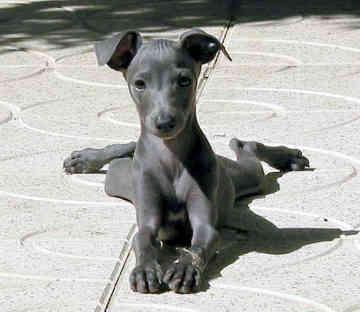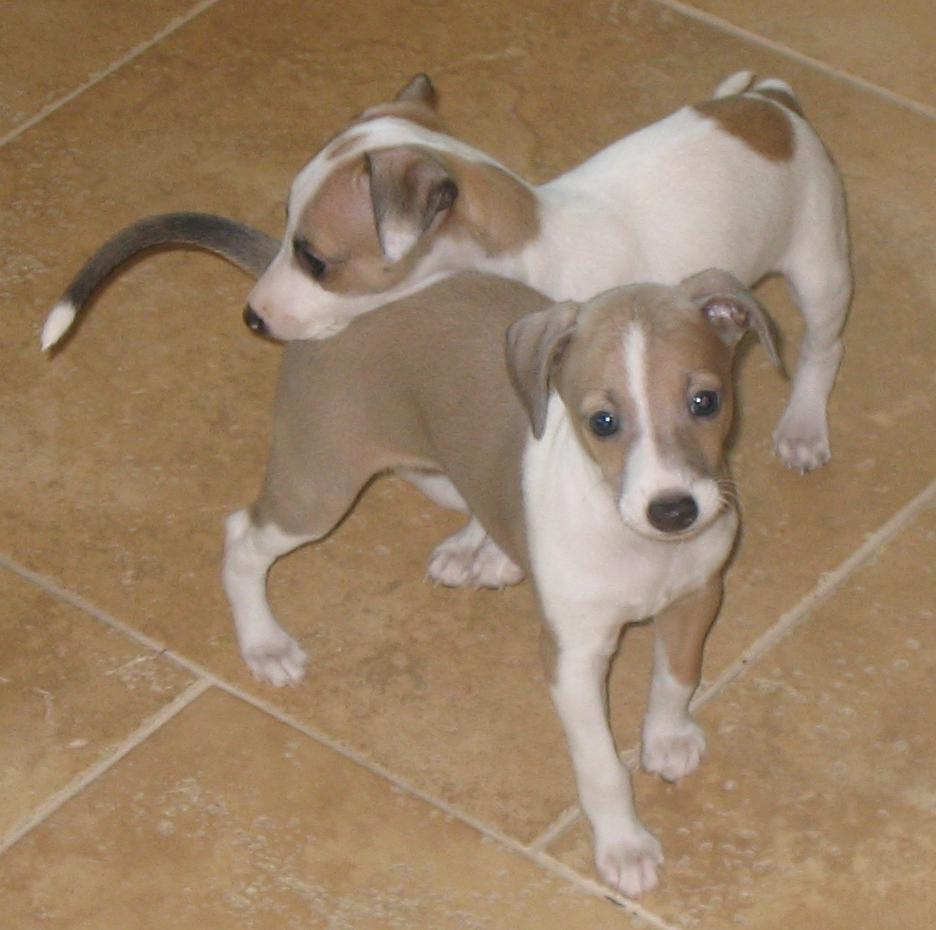The first image is the image on the left, the second image is the image on the right. Analyze the images presented: Is the assertion "There are more dogs in the right image than in the left." valid? Answer yes or no. Yes. 